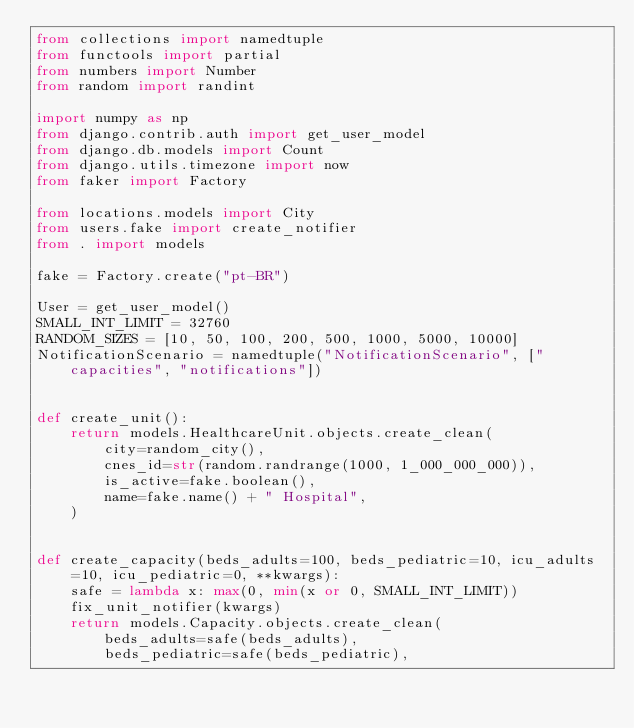Convert code to text. <code><loc_0><loc_0><loc_500><loc_500><_Python_>from collections import namedtuple
from functools import partial
from numbers import Number
from random import randint

import numpy as np
from django.contrib.auth import get_user_model
from django.db.models import Count
from django.utils.timezone import now
from faker import Factory

from locations.models import City
from users.fake import create_notifier
from . import models

fake = Factory.create("pt-BR")

User = get_user_model()
SMALL_INT_LIMIT = 32760
RANDOM_SIZES = [10, 50, 100, 200, 500, 1000, 5000, 10000]
NotificationScenario = namedtuple("NotificationScenario", ["capacities", "notifications"])


def create_unit():
    return models.HealthcareUnit.objects.create_clean(
        city=random_city(),
        cnes_id=str(random.randrange(1000, 1_000_000_000)),
        is_active=fake.boolean(),
        name=fake.name() + " Hospital",
    )


def create_capacity(beds_adults=100, beds_pediatric=10, icu_adults=10, icu_pediatric=0, **kwargs):
    safe = lambda x: max(0, min(x or 0, SMALL_INT_LIMIT))
    fix_unit_notifier(kwargs)
    return models.Capacity.objects.create_clean(
        beds_adults=safe(beds_adults),
        beds_pediatric=safe(beds_pediatric),</code> 